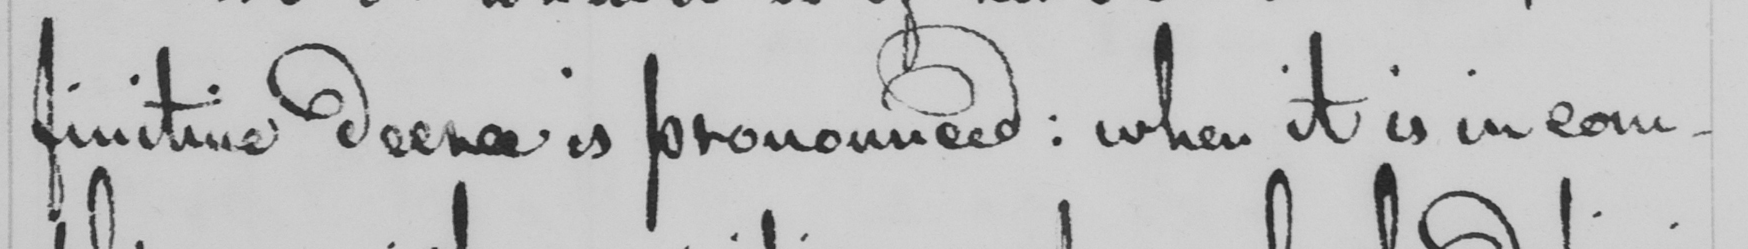Please transcribe the handwritten text in this image. finitive decree is pronounced :  when it is in com- 